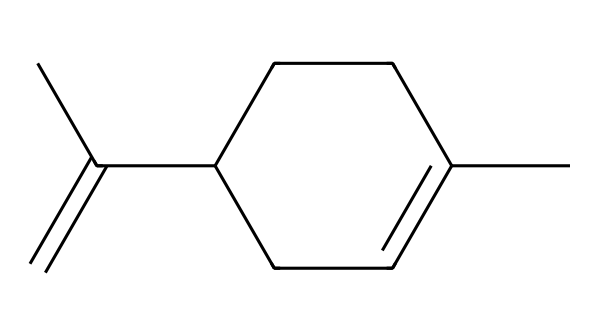How many carbon atoms are in limonene? By examining the SMILES representation, you can count the number of 'C' characters, which signify carbon atoms. In this case, there are 10 'C' characters in total.
Answer: 10 What functional groups are present in limonene? In the SMILES structure, limonene contains a double bond (shown by 'C=C'). This indicates it is an alkene. However, it does not contain functional groups such as alcohols or acids in this representation.
Answer: alkene How many hydrogen atoms are associated with limonene? The general formula for alkenes is CnH2n, where n is the number of carbon atoms. For limonene (with 10 carbons), the number of hydrogen atoms would typically be 2(10) = 20, but due to the double bond, we need to subtract 2. Therefore, there are 18 hydrogen atoms.
Answer: 18 What is the molecular formula of limonene? Based on the counts of carbon (C) and hydrogen (H) atoms derived from the analysis (10 carbons and 18 hydrogens), the molecular formula can be derived as C10H18.
Answer: C10H18 What characteristic odor does limonene possess? Limonene is commonly known for its citrus scent, which is characteristic of citrus fruits like oranges and lemons. This is part of the reason it is widely used in fragrances and air fresheners.
Answer: citrus Is limonene considered a terpene? Limonene, based on its structure and classification, is indeed categorized as a terpene because it is derived from plant sources and primarily composed of carbon and hydrogen, fitting the criteria of terpenes.
Answer: yes What is the primary use of limonene in vehicles? In the context of vehicle interiors, limonene is primarily used for its refreshing scent, making it popular in car air fresheners and cleaning products to enhance sensory experiences inside the car.
Answer: air fresheners 